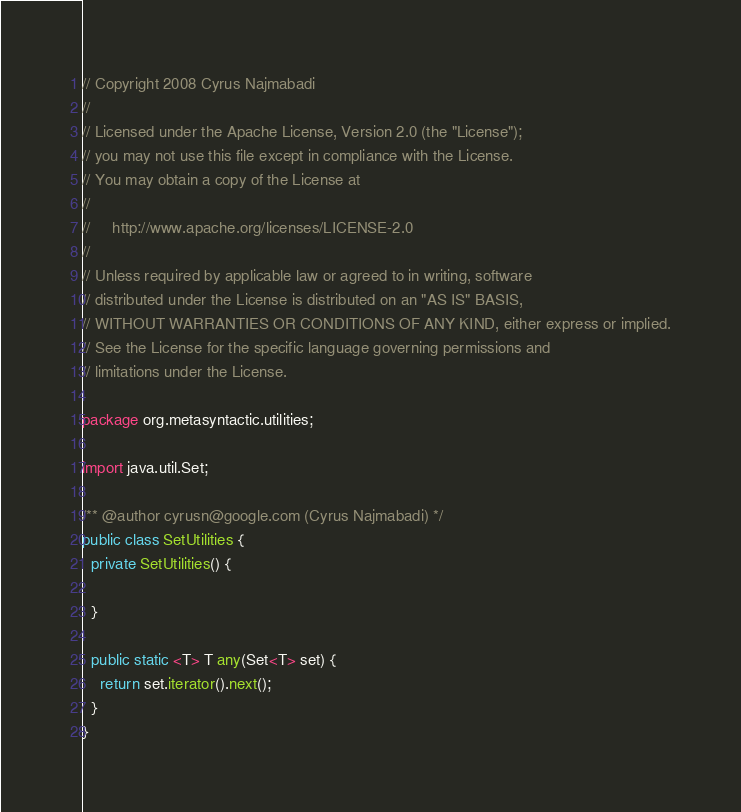Convert code to text. <code><loc_0><loc_0><loc_500><loc_500><_Java_>// Copyright 2008 Cyrus Najmabadi
//
// Licensed under the Apache License, Version 2.0 (the "License");
// you may not use this file except in compliance with the License.
// You may obtain a copy of the License at
//
//     http://www.apache.org/licenses/LICENSE-2.0
//
// Unless required by applicable law or agreed to in writing, software
// distributed under the License is distributed on an "AS IS" BASIS,
// WITHOUT WARRANTIES OR CONDITIONS OF ANY KIND, either express or implied.
// See the License for the specific language governing permissions and
// limitations under the License.

package org.metasyntactic.utilities;

import java.util.Set;

/** @author cyrusn@google.com (Cyrus Najmabadi) */
public class SetUtilities {
  private SetUtilities() {

  }

  public static <T> T any(Set<T> set) {
    return set.iterator().next();
  }
}
</code> 